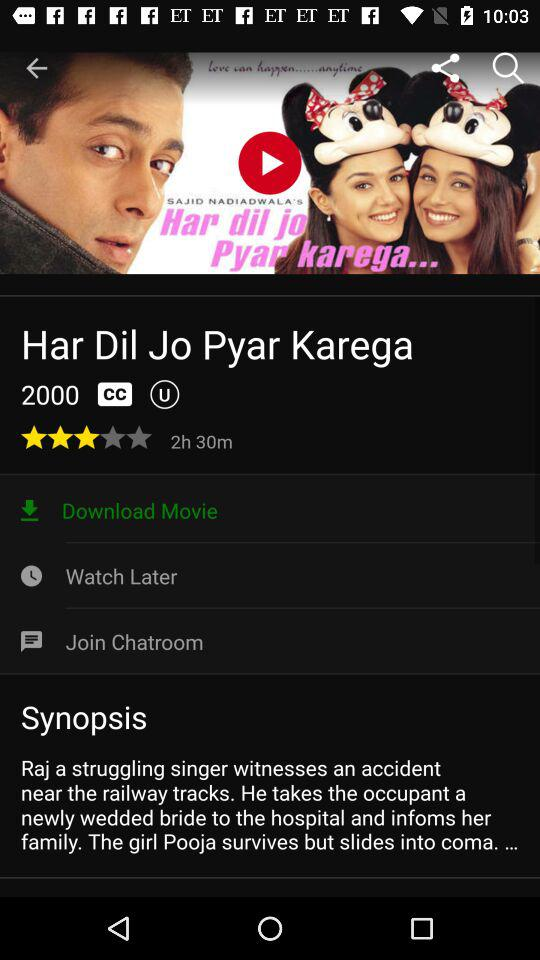What is the time duration? The time duration is 2 hours 30 minutes. 